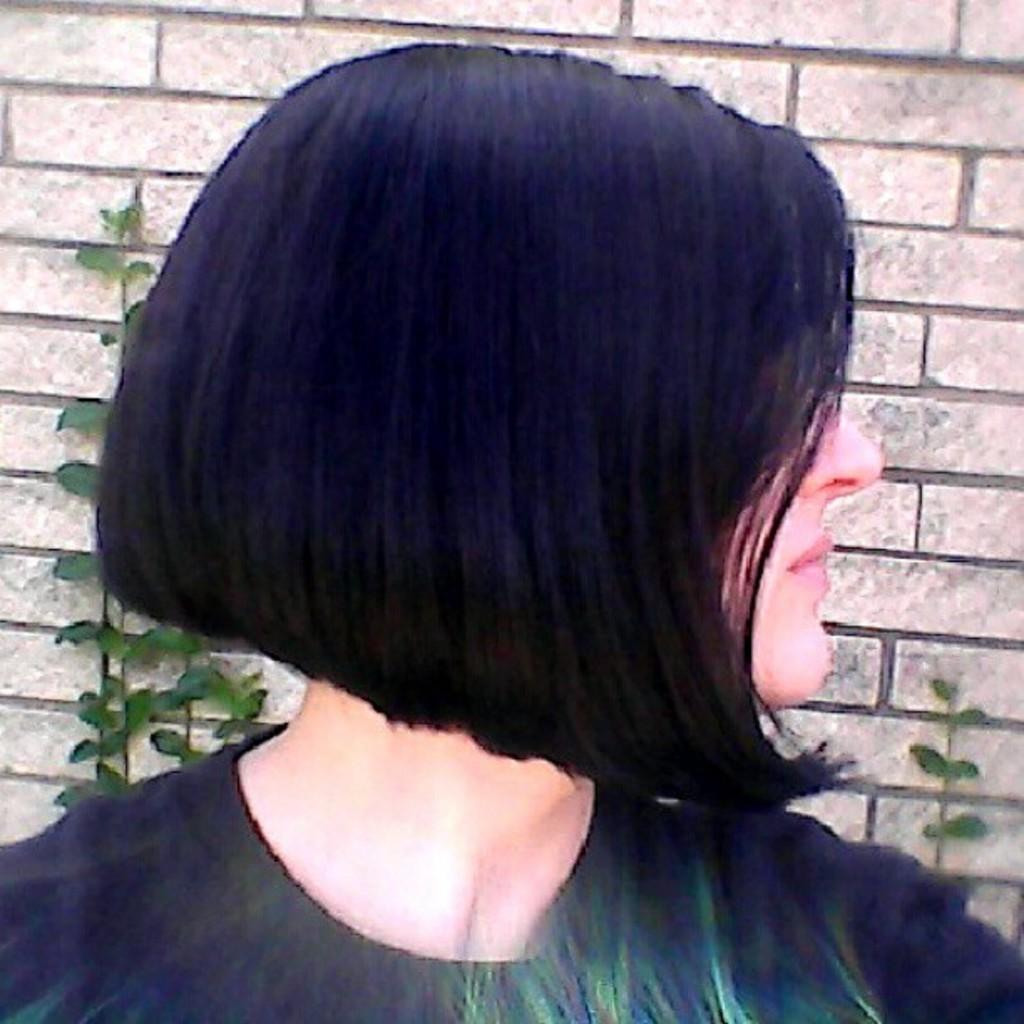Please provide a concise description of this image. In this picture there is a girl in the center of the image and there are plants behind her. 